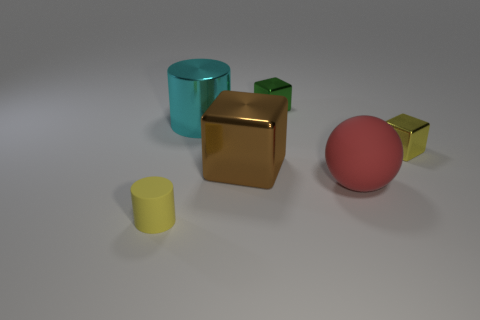Add 2 tiny objects. How many objects exist? 8 Subtract all cylinders. How many objects are left? 4 Add 6 large rubber things. How many large rubber things exist? 7 Subtract 0 red cylinders. How many objects are left? 6 Subtract all small purple metallic cylinders. Subtract all tiny yellow rubber objects. How many objects are left? 5 Add 2 tiny yellow matte objects. How many tiny yellow matte objects are left? 3 